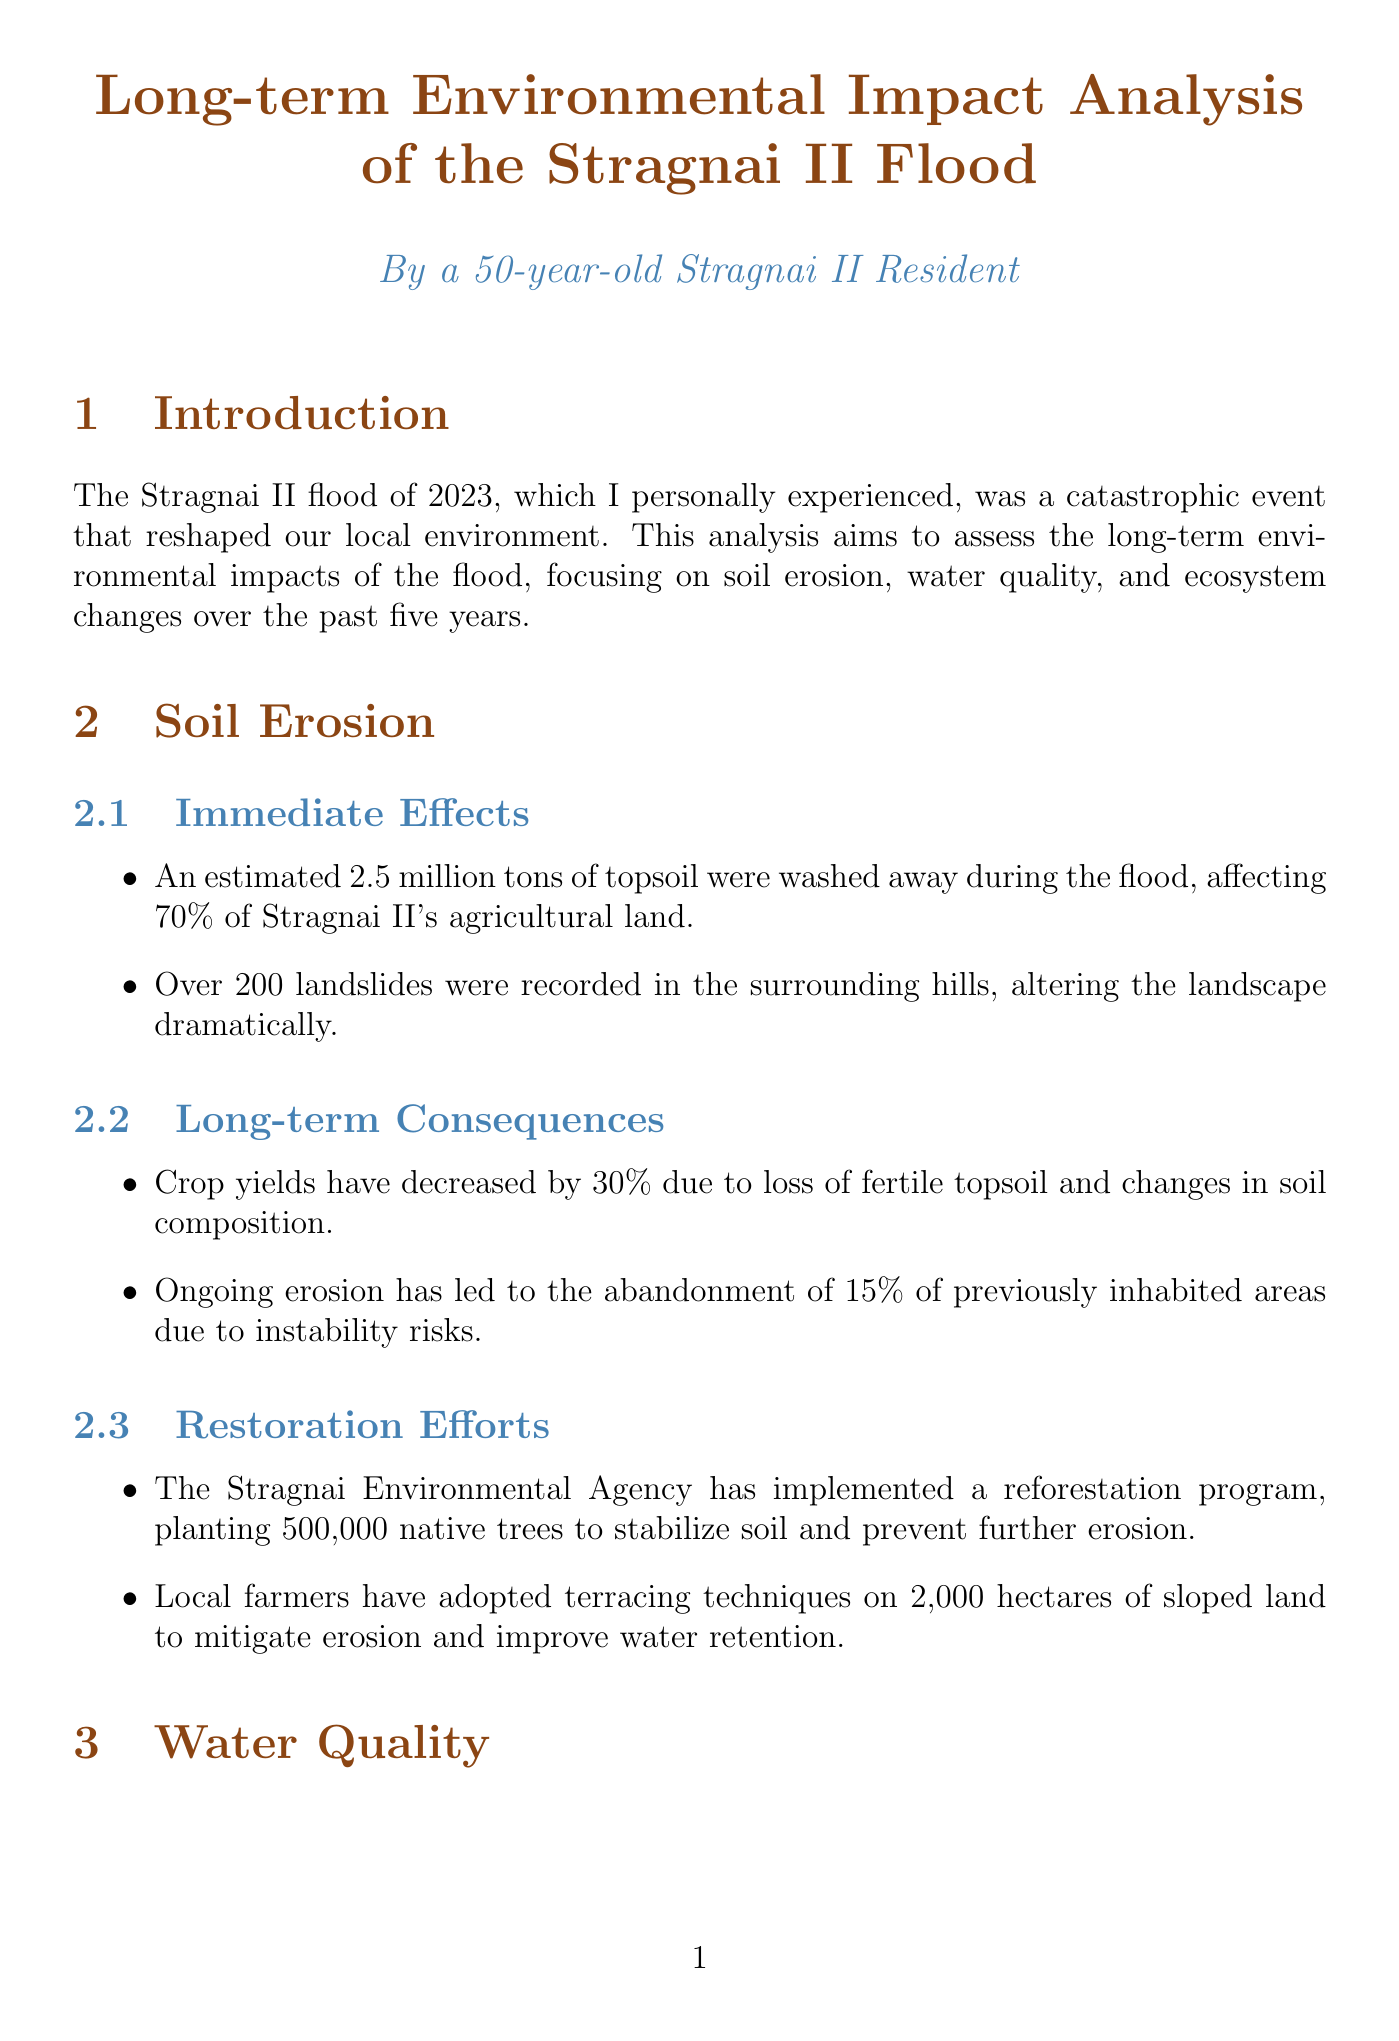What was washed away during the flood? An estimated 2.5 million tons of topsoil were washed away, which is discussed in the immediate effects of soil erosion.
Answer: topsoil What percentage of crops has yield decreased? The document states that crop yields have decreased by 30% due to loss of fertile topsoil and changes in soil composition.
Answer: 30% How many landslides were recorded? Over 200 landslides were recorded in the surrounding hills, as noted in the immediate effects of soil erosion.
Answer: 200 What is the investment amount for water treatment facilities? The document mentions that the Stragnai Water Authority has invested €50 million in upgrading water treatment facilities.
Answer: €50 million What percentage of aquifers were contaminated? The report indicates that contamination of aquifers has affected drinking water quality for 60% of Stragnai II's population.
Answer: 60% What habitat is being restored? The Stragnai Wildlife Trust has initiated a project to restore wetland habitat, as described in the recovery initiatives section.
Answer: wetland habitat What has happened to the Stragnai spotted frog population? The document evaluates that local populations of the endangered Stragnai spotted frog have declined by 70% since the flood.
Answer: 70% How much native trees were planted for reforestation? The restoration efforts documented that 500,000 native trees were planted to stabilize soil and prevent further erosion.
Answer: 500,000 What was the decline in the local ecotourism industry? The report states that the local ecotourism industry has seen a 60% decline in visitors due to habitat destruction.
Answer: 60% 